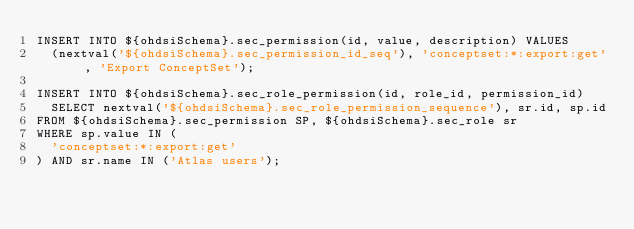<code> <loc_0><loc_0><loc_500><loc_500><_SQL_>INSERT INTO ${ohdsiSchema}.sec_permission(id, value, description) VALUES
  (nextval('${ohdsiSchema}.sec_permission_id_seq'), 'conceptset:*:export:get', 'Export ConceptSet');

INSERT INTO ${ohdsiSchema}.sec_role_permission(id, role_id, permission_id)
  SELECT nextval('${ohdsiSchema}.sec_role_permission_sequence'), sr.id, sp.id
FROM ${ohdsiSchema}.sec_permission SP, ${ohdsiSchema}.sec_role sr
WHERE sp.value IN (
  'conceptset:*:export:get'
) AND sr.name IN ('Atlas users');</code> 